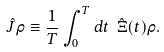Convert formula to latex. <formula><loc_0><loc_0><loc_500><loc_500>\hat { J } \rho \equiv \frac { 1 } { T } \int _ { 0 } ^ { T } d t \ \hat { \Xi } ( t ) \rho .</formula> 